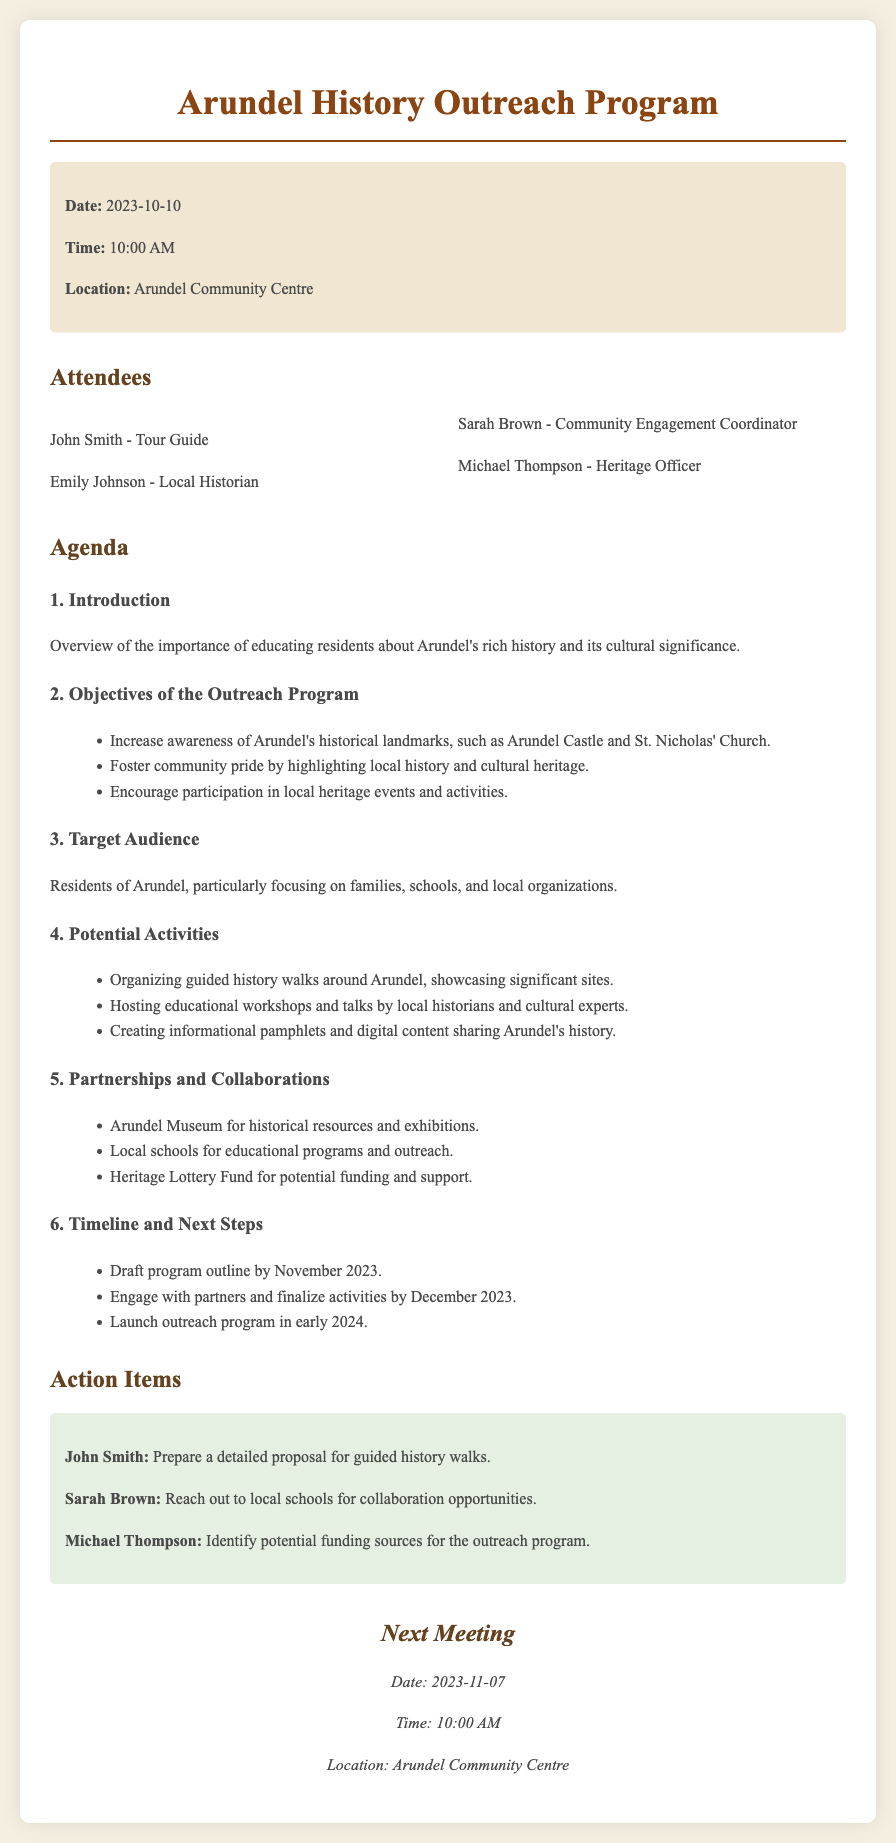what was the date of the meeting? The meeting took place on October 10, 2023.
Answer: October 10, 2023 who is the local historian that attended? Emily Johnson is the local historian mentioned in the attendees' list.
Answer: Emily Johnson what are one of the objectives of the outreach program? One objective is to increase awareness of Arundel's historical landmarks.
Answer: Increase awareness of Arundel's historical landmarks when is the next meeting scheduled? The next meeting is scheduled for November 7, 2023.
Answer: November 7, 2023 who is responsible for preparing a proposal for guided history walks? John Smith is tasked with preparing the proposal.
Answer: John Smith which organization is mentioned for potential funding support? The Heritage Lottery Fund is listed as a potential funding source.
Answer: Heritage Lottery Fund which location is targeted as the primary audience for the outreach program? The primary audience targeted is the residents of Arundel.
Answer: Residents of Arundel what activity involves showcasing significant sites in Arundel? Organizing guided history walks around Arundel involves showcasing significant sites.
Answer: Organizing guided history walks what month is the draft program outline expected to be completed? The draft program outline is expected to be completed by November 2023.
Answer: November 2023 